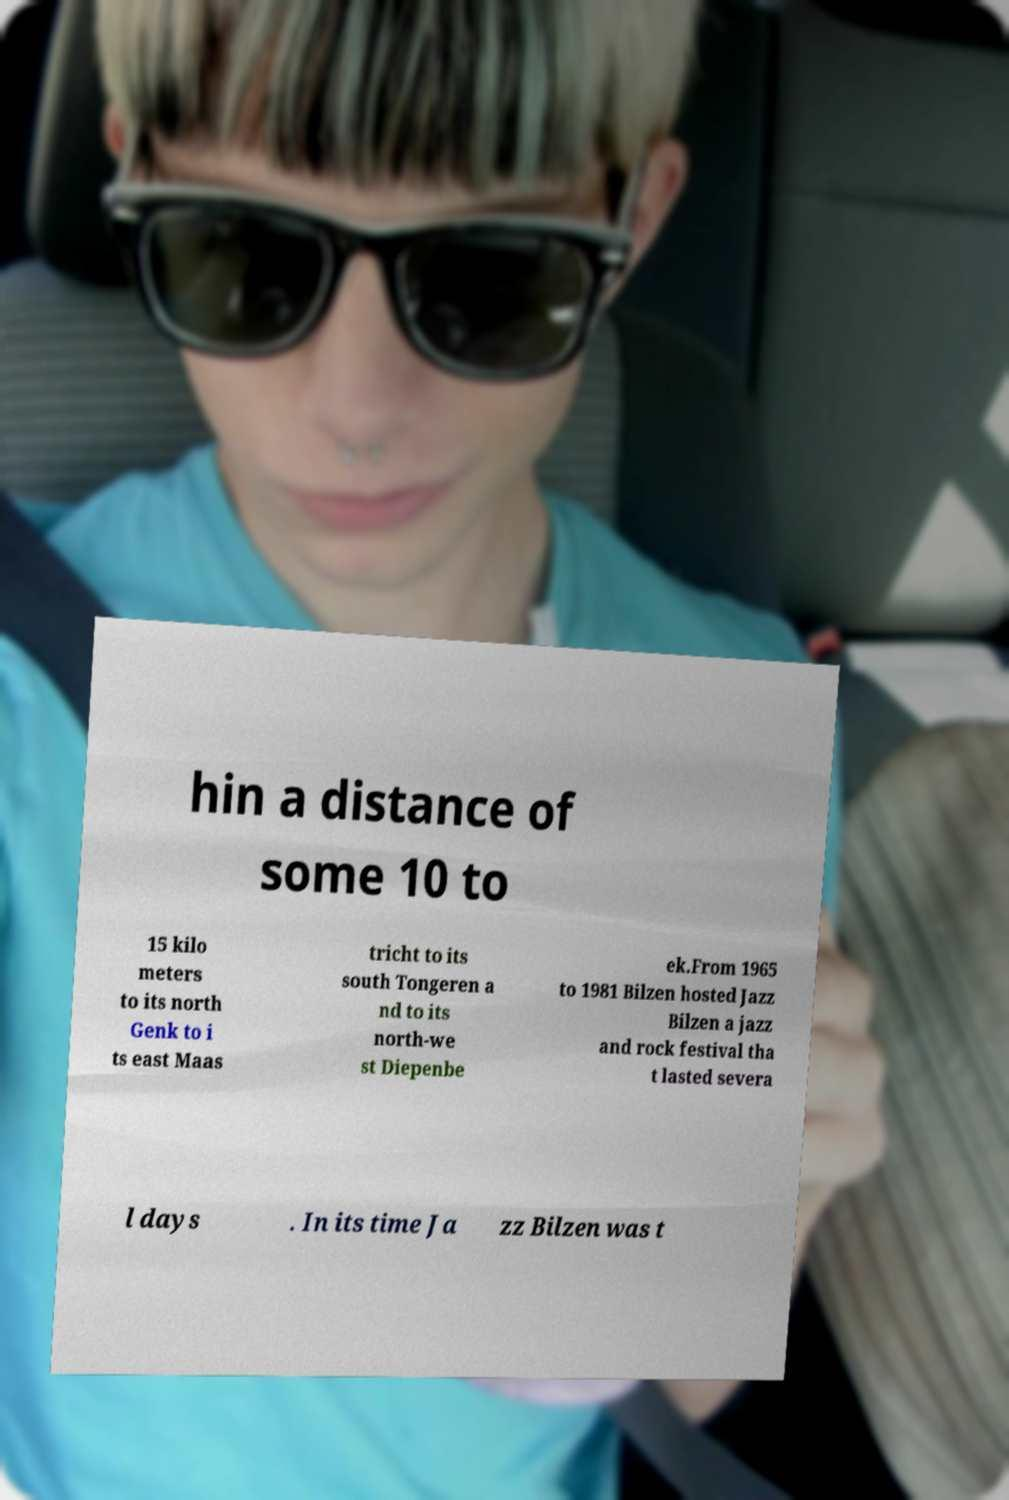There's text embedded in this image that I need extracted. Can you transcribe it verbatim? hin a distance of some 10 to 15 kilo meters to its north Genk to i ts east Maas tricht to its south Tongeren a nd to its north-we st Diepenbe ek.From 1965 to 1981 Bilzen hosted Jazz Bilzen a jazz and rock festival tha t lasted severa l days . In its time Ja zz Bilzen was t 